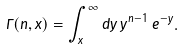<formula> <loc_0><loc_0><loc_500><loc_500>\Gamma ( n , x ) = \int _ { x } ^ { \infty } d y \, y ^ { n - 1 } \, e ^ { - y } .</formula> 